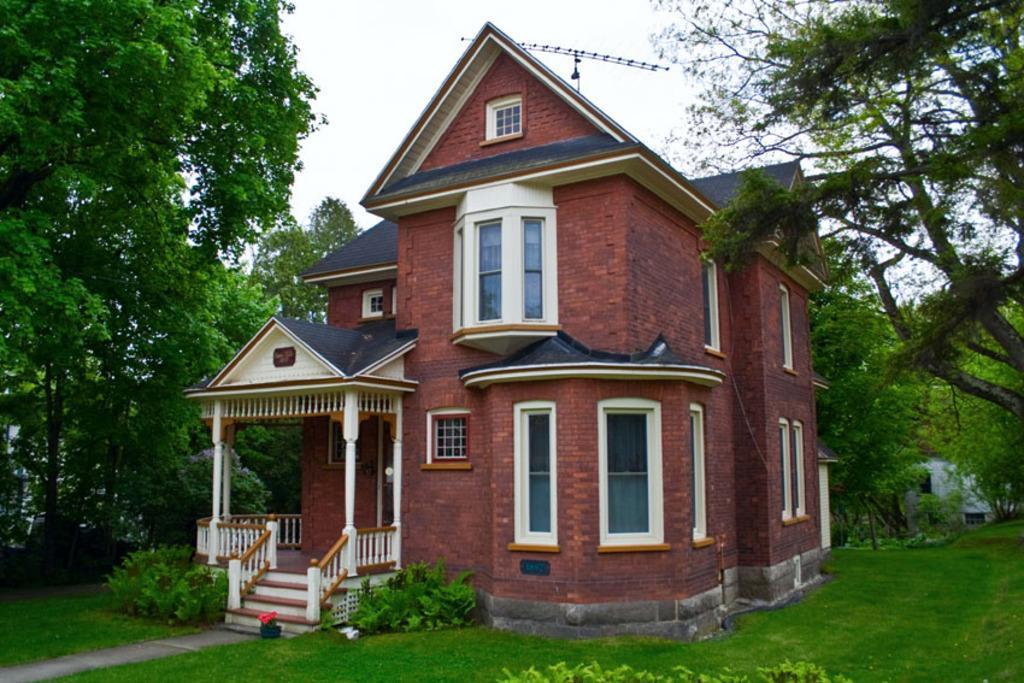Can you describe this image briefly? As we can see in the image there is a building which is made up of red bricks and in front of the building there is a garden and the ground is covered with grass and beside the building there are trees and on the top there is a clear sky and the back of the building there are trees. 